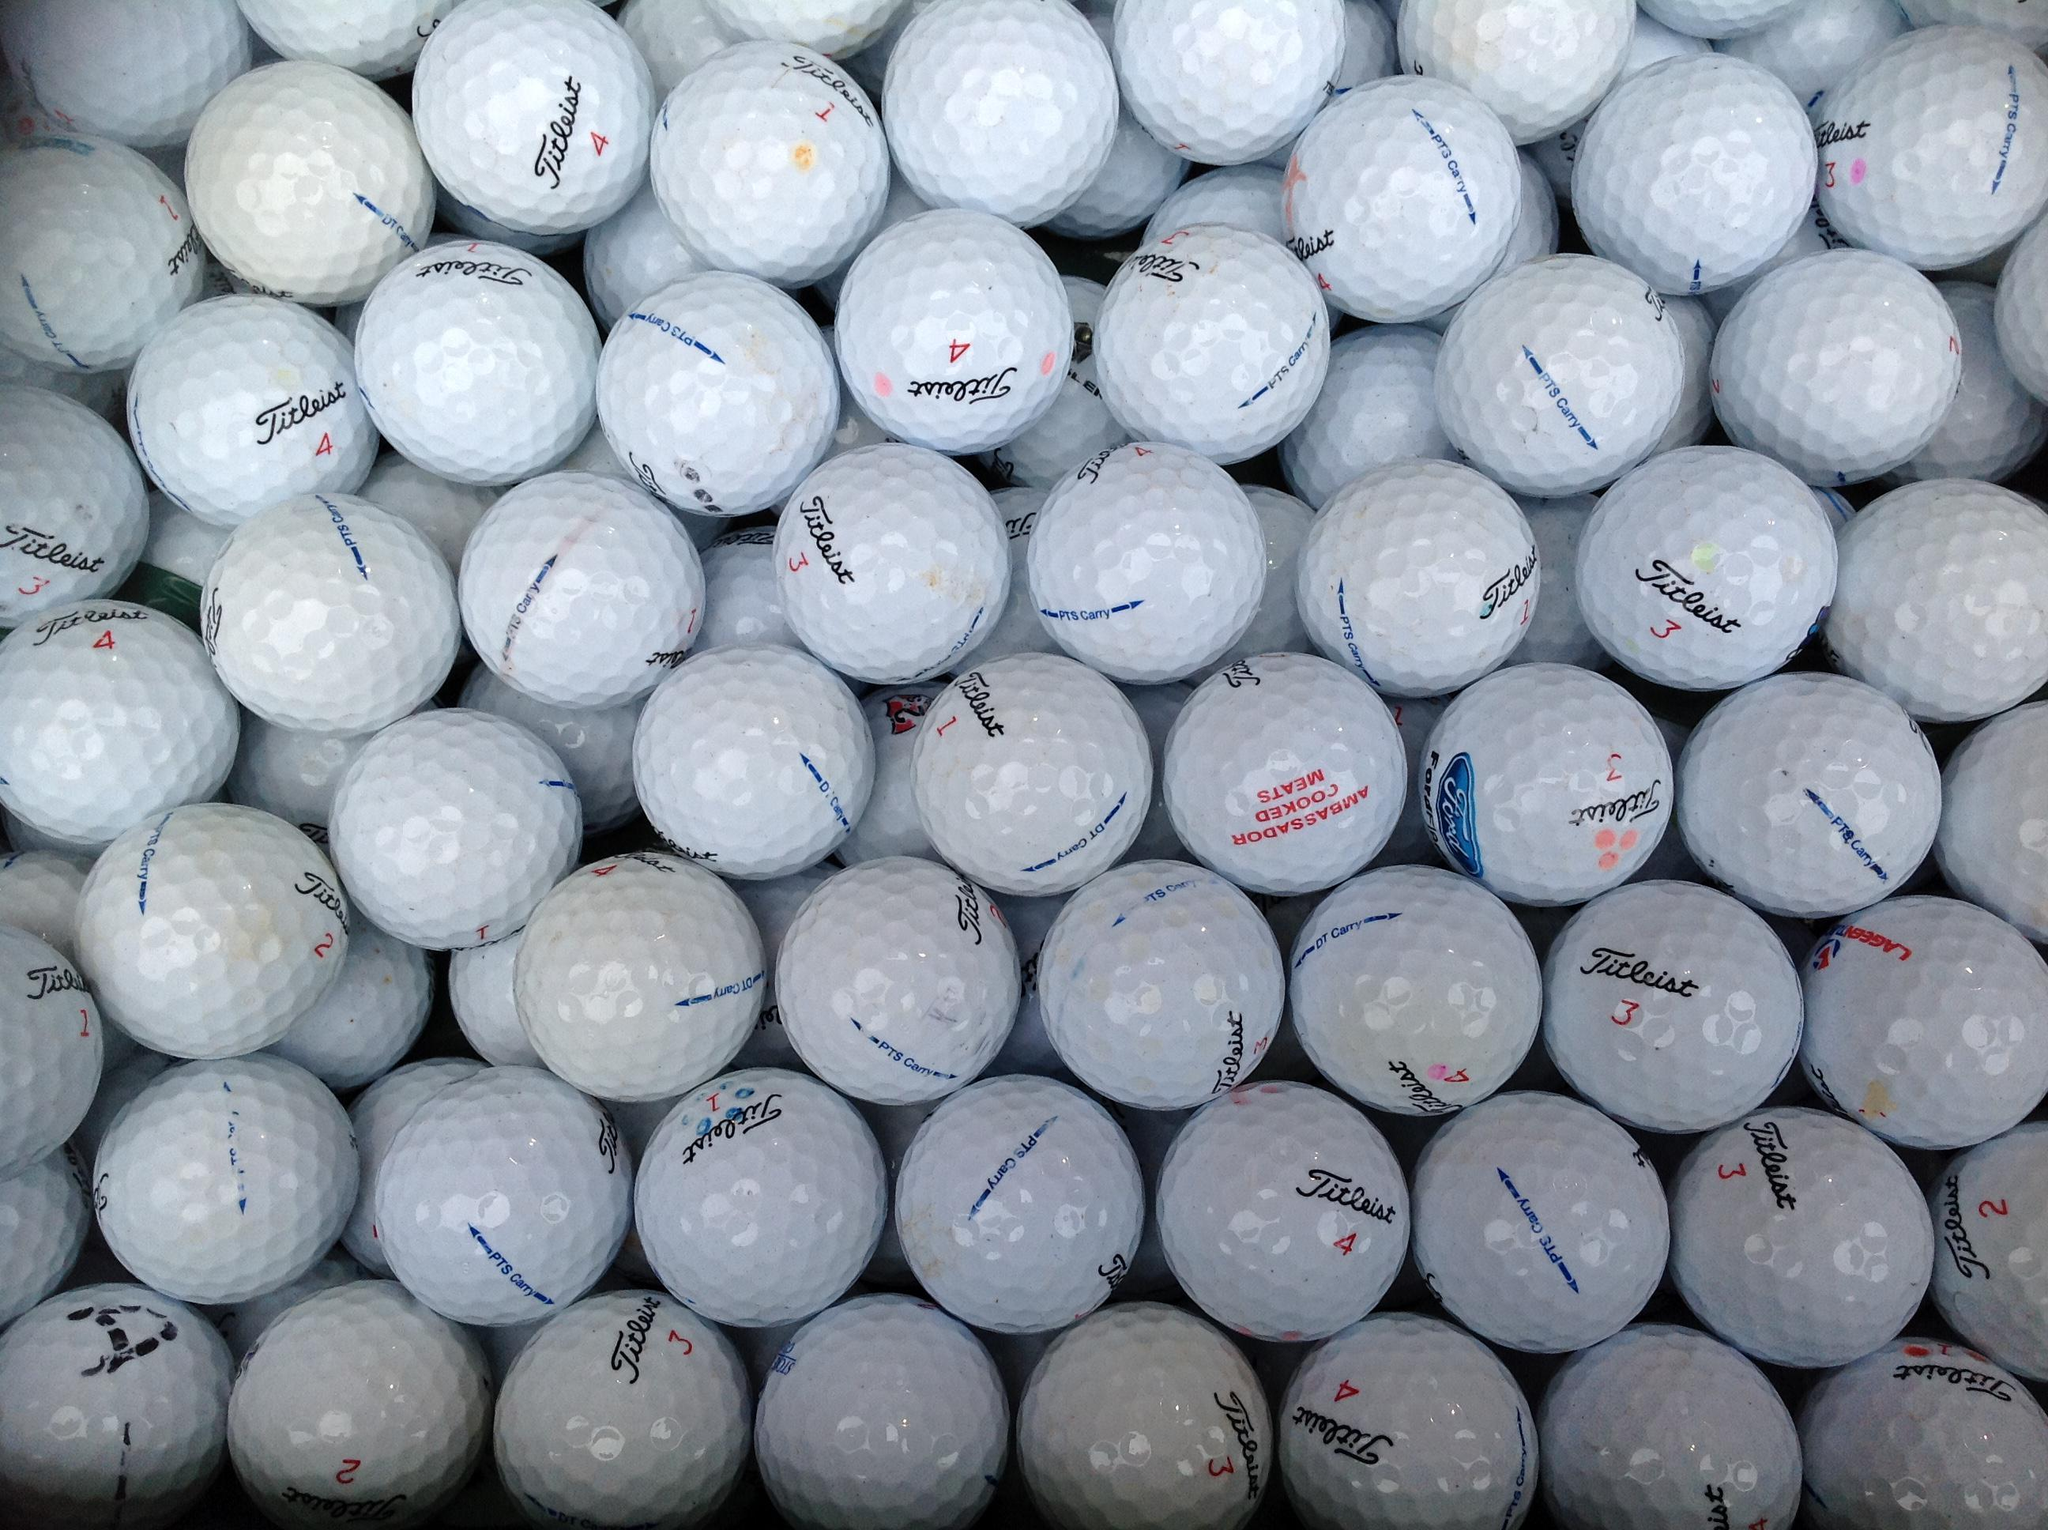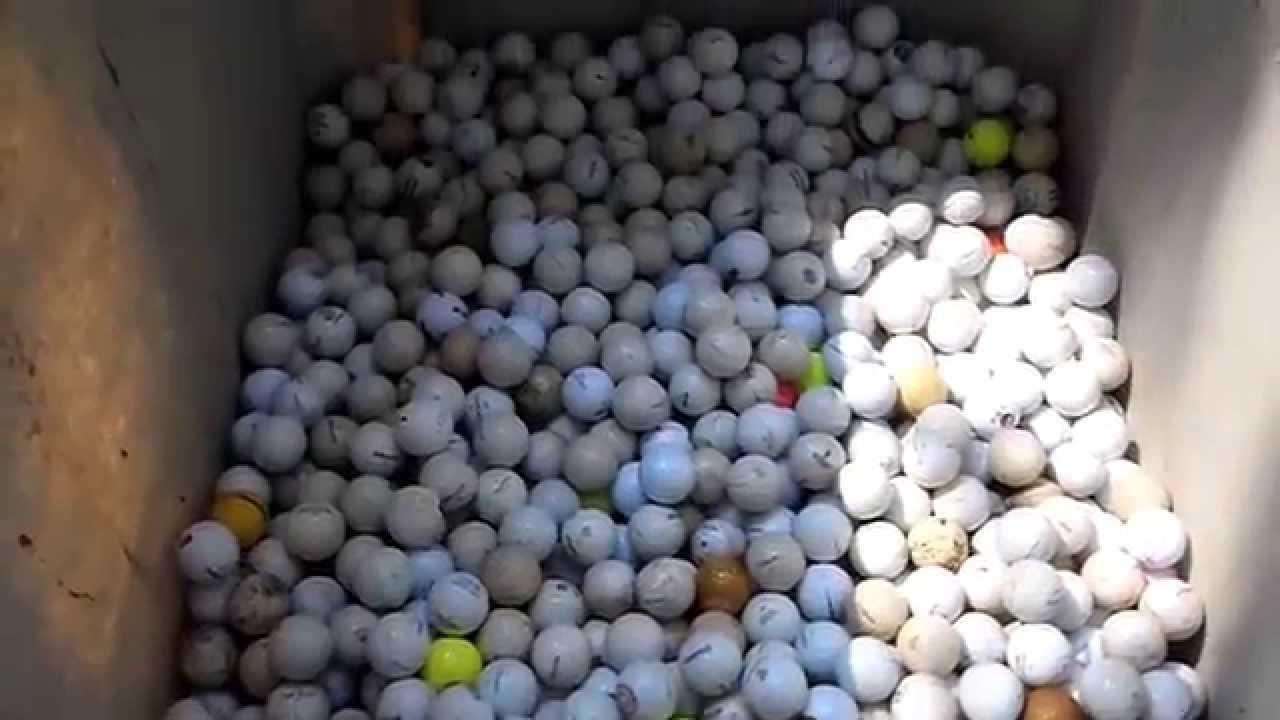The first image is the image on the left, the second image is the image on the right. Examine the images to the left and right. Is the description "Some of the balls are colorful." accurate? Answer yes or no. Yes. 